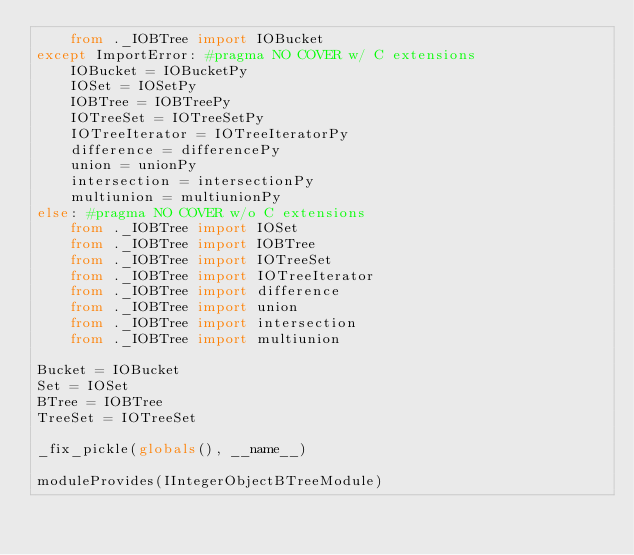Convert code to text. <code><loc_0><loc_0><loc_500><loc_500><_Python_>    from ._IOBTree import IOBucket
except ImportError: #pragma NO COVER w/ C extensions
    IOBucket = IOBucketPy
    IOSet = IOSetPy
    IOBTree = IOBTreePy
    IOTreeSet = IOTreeSetPy
    IOTreeIterator = IOTreeIteratorPy
    difference = differencePy
    union = unionPy
    intersection = intersectionPy
    multiunion = multiunionPy
else: #pragma NO COVER w/o C extensions
    from ._IOBTree import IOSet
    from ._IOBTree import IOBTree
    from ._IOBTree import IOTreeSet
    from ._IOBTree import IOTreeIterator
    from ._IOBTree import difference
    from ._IOBTree import union
    from ._IOBTree import intersection
    from ._IOBTree import multiunion

Bucket = IOBucket
Set = IOSet
BTree = IOBTree
TreeSet = IOTreeSet

_fix_pickle(globals(), __name__)

moduleProvides(IIntegerObjectBTreeModule)
</code> 